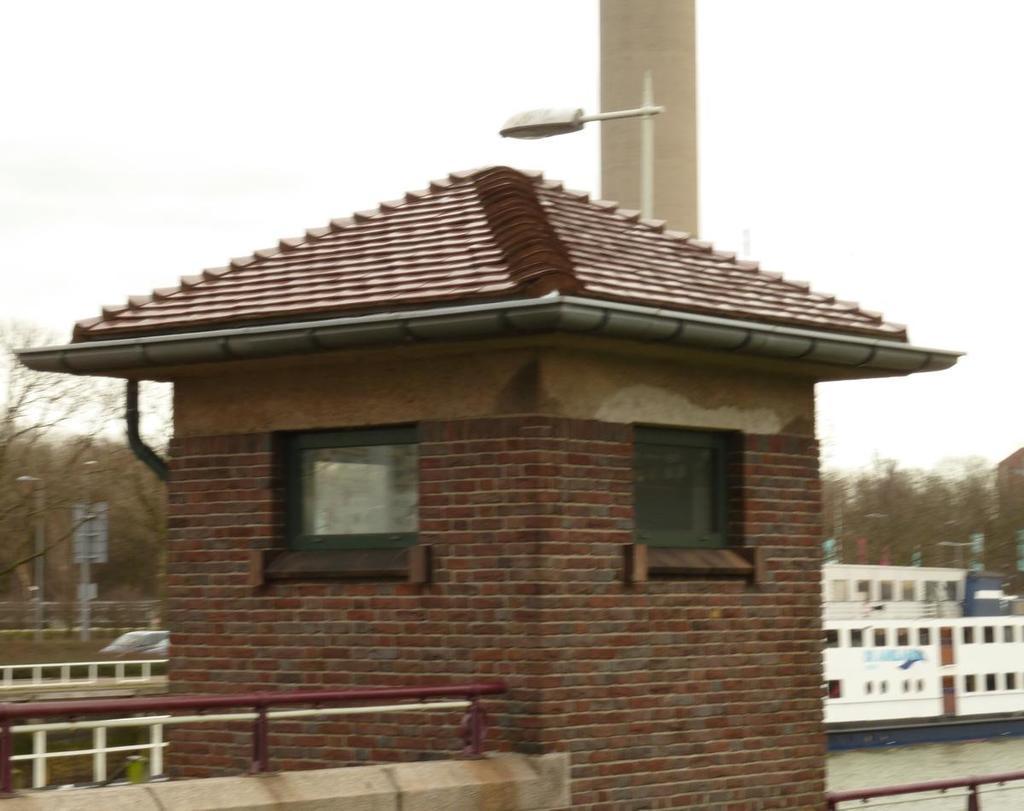Can you describe this image briefly? In this image we can see a shed with brick wall, windows. Near to that there are railings. Also there is a light pole. In the background there are trees, water and a boat with windows. Also there is sky. And there are poles on the left side. 